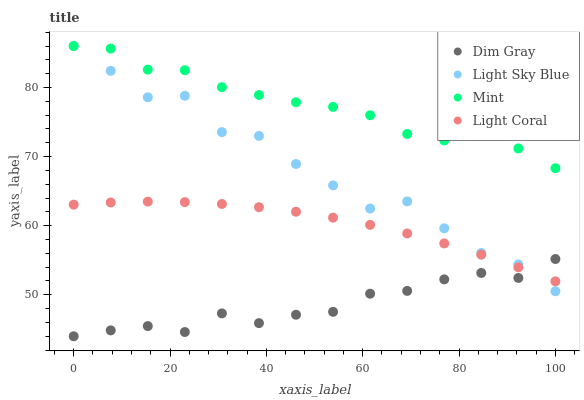Does Dim Gray have the minimum area under the curve?
Answer yes or no. Yes. Does Mint have the maximum area under the curve?
Answer yes or no. Yes. Does Mint have the minimum area under the curve?
Answer yes or no. No. Does Dim Gray have the maximum area under the curve?
Answer yes or no. No. Is Light Coral the smoothest?
Answer yes or no. Yes. Is Light Sky Blue the roughest?
Answer yes or no. Yes. Is Dim Gray the smoothest?
Answer yes or no. No. Is Dim Gray the roughest?
Answer yes or no. No. Does Dim Gray have the lowest value?
Answer yes or no. Yes. Does Mint have the lowest value?
Answer yes or no. No. Does Light Sky Blue have the highest value?
Answer yes or no. Yes. Does Dim Gray have the highest value?
Answer yes or no. No. Is Light Coral less than Mint?
Answer yes or no. Yes. Is Mint greater than Light Coral?
Answer yes or no. Yes. Does Mint intersect Light Sky Blue?
Answer yes or no. Yes. Is Mint less than Light Sky Blue?
Answer yes or no. No. Is Mint greater than Light Sky Blue?
Answer yes or no. No. Does Light Coral intersect Mint?
Answer yes or no. No. 